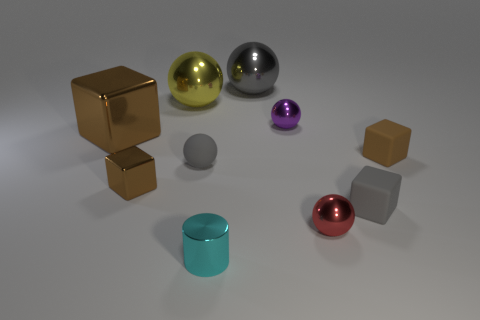Add 2 small gray matte cubes. How many small gray matte cubes exist? 3 Subtract all yellow spheres. How many spheres are left? 4 Subtract all tiny metal spheres. How many spheres are left? 3 Subtract 1 red spheres. How many objects are left? 9 Subtract all cubes. How many objects are left? 6 Subtract 3 spheres. How many spheres are left? 2 Subtract all brown cubes. Subtract all purple balls. How many cubes are left? 1 Subtract all gray balls. How many yellow blocks are left? 0 Subtract all tiny red metallic objects. Subtract all tiny purple spheres. How many objects are left? 8 Add 5 small cyan cylinders. How many small cyan cylinders are left? 6 